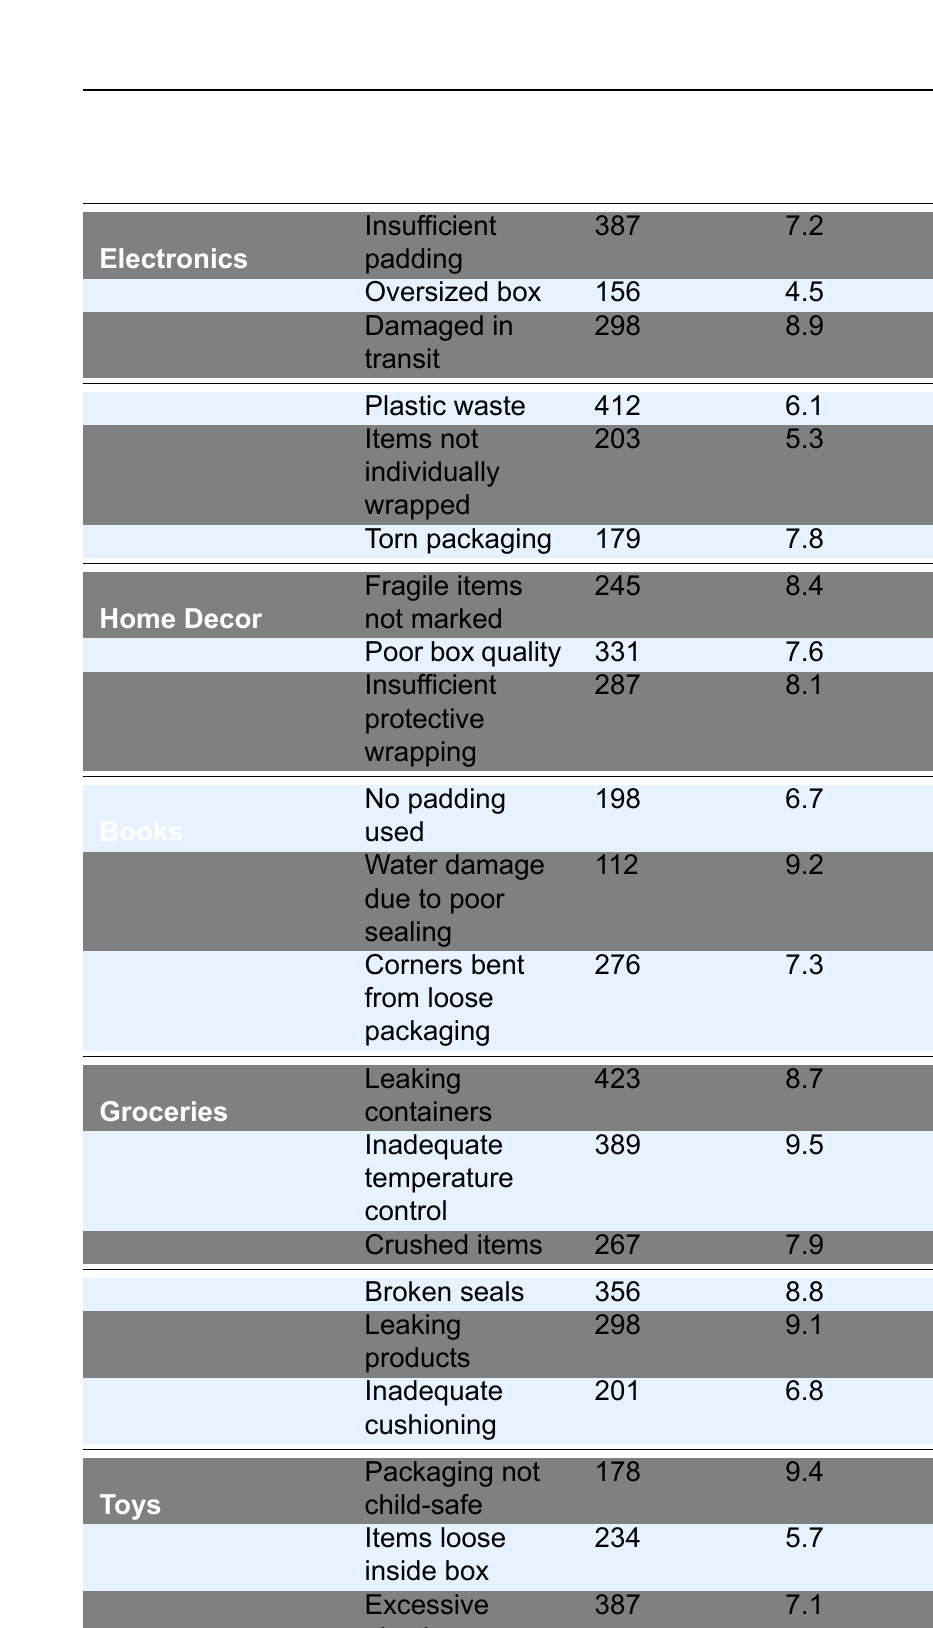What is the complaint count for "Insufficient padding" in Electronics? The table indicates the complaint count for "Insufficient padding" under the Electronics category is listed as 387.
Answer: 387 Which product category has the highest average severity score? By reviewing the average severity scores in the table, "Groceries" has the highest average severity of 9.5.
Answer: Groceries How many complaints were reported for "Torn packaging" in the Clothing category? Looking at the table, the Clothing category shows 179 complaints reported for "Torn packaging."
Answer: 179 What is the total complaint count for the Toys category? The table shows three complaint counts under Toys: 178 (packaging not child-safe), 234 (items loose inside box), and 387 (excessive plastic waste). Adding these gives: 178 + 234 + 387 = 799.
Answer: 799 Is there a complaint type in the Electronics category with an average severity above 8? The average severity for "Damaged in transit" in Electronics is 8.9, which is above 8. Therefore, this is true.
Answer: Yes What is the difference in complaint counts between "Leaking containers" and "Crushed items" in Groceries? The complaint count for "Leaking containers" is 423 and for "Crushed items" it is 267. Calculating the difference gives: 423 - 267 = 156.
Answer: 156 How many total complaints were reported across all product categories? We need to sum the complaint counts for all categories. Adding the counts: 387 + 156 + 298 + 412 + 203 + 179 + 245 + 331 + 287 + 198 + 112 + 276 + 423 + 389 + 267 + 356 + 298 + 201 + 178 + 234 + 387 = 4702.
Answer: 4702 Which product category has the highest complaint count for "Plastic waste"? The table shows "Plastic waste" has a complaint count of 412 in the Clothing category, which is the highest among all categories for that type.
Answer: Clothing What is the average severity for "Water damage due to poor sealing" and "Corners bent from loose packaging"? The average severity for "Water damage due to poor sealing" is 9.2 and for "Corners bent from loose packaging" it is 7.3. The average of these two values is (9.2 + 7.3) / 2 = 8.25.
Answer: 8.25 Is the complaint count for "Excessive plastic waste" in Toys higher than that for "Insufficient protective wrapping" in Home Decor? The complaint count for "Excessive plastic waste" is 387, and for "Insufficient protective wrapping" it is 287. Since 387 is greater than 287, the statement is true.
Answer: Yes 